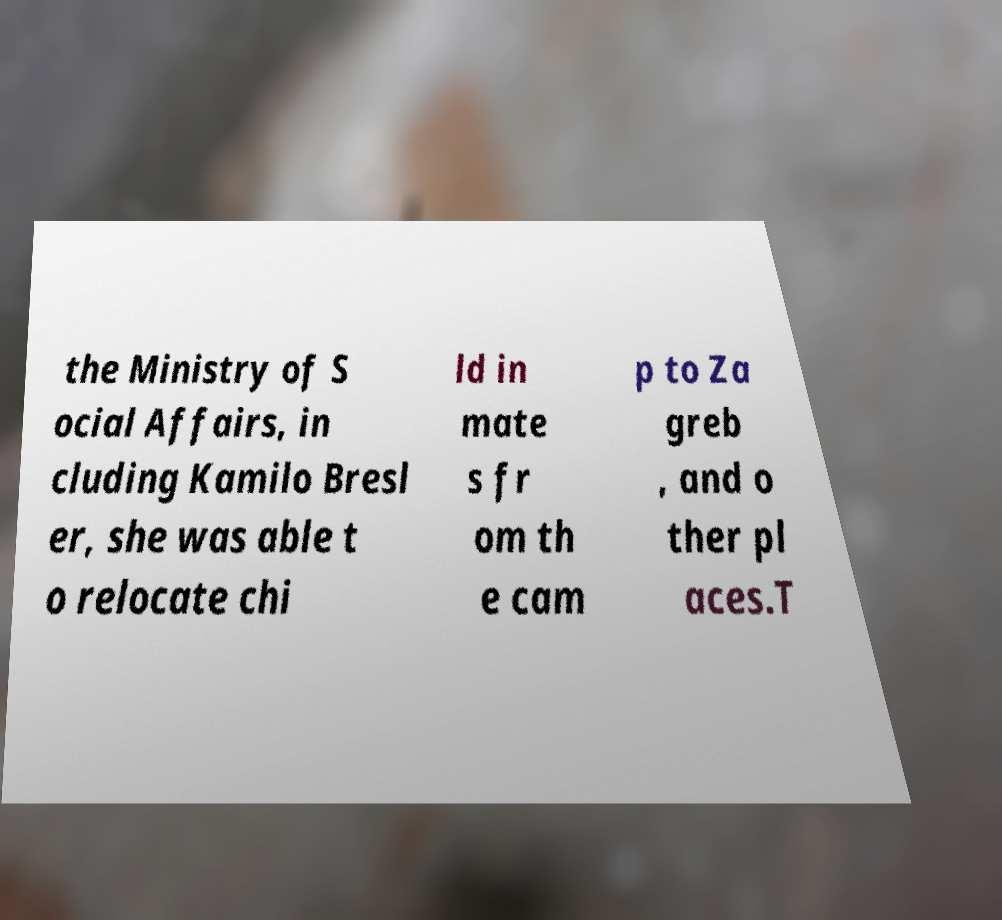Can you read and provide the text displayed in the image?This photo seems to have some interesting text. Can you extract and type it out for me? the Ministry of S ocial Affairs, in cluding Kamilo Bresl er, she was able t o relocate chi ld in mate s fr om th e cam p to Za greb , and o ther pl aces.T 